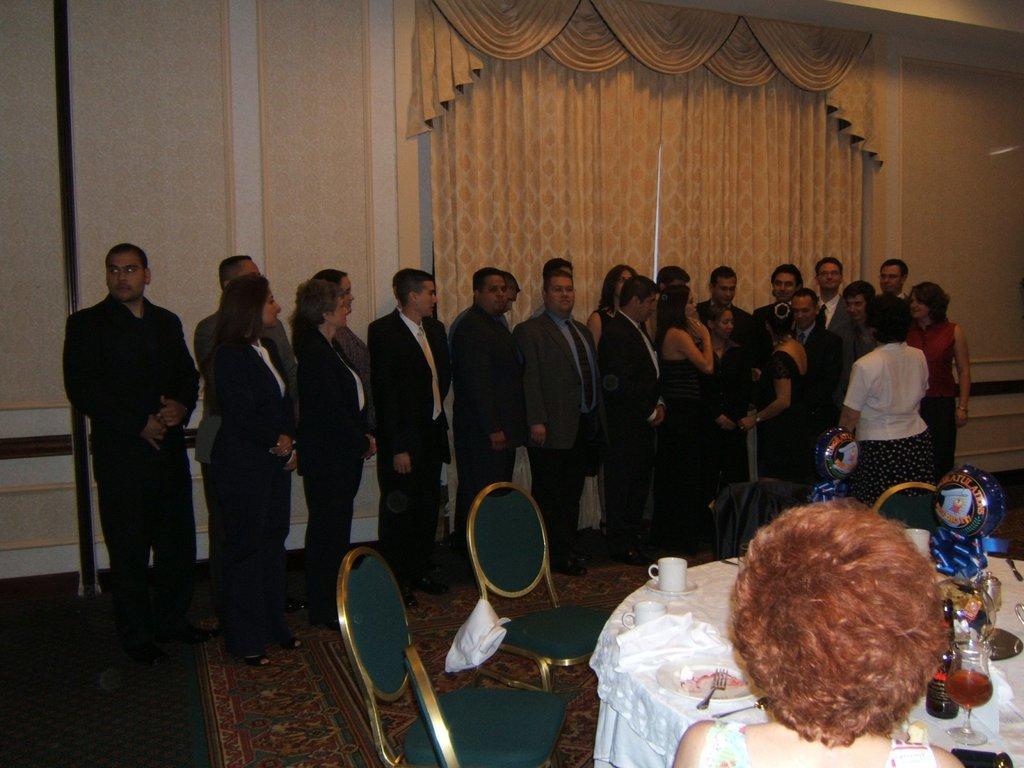Describe this image in one or two sentences. There is a person and we can see chairs and we can see glass, plate, cups, fork, bottle and objects on the table. There are people standing on the floor. In the background we can see walls and curtains. 